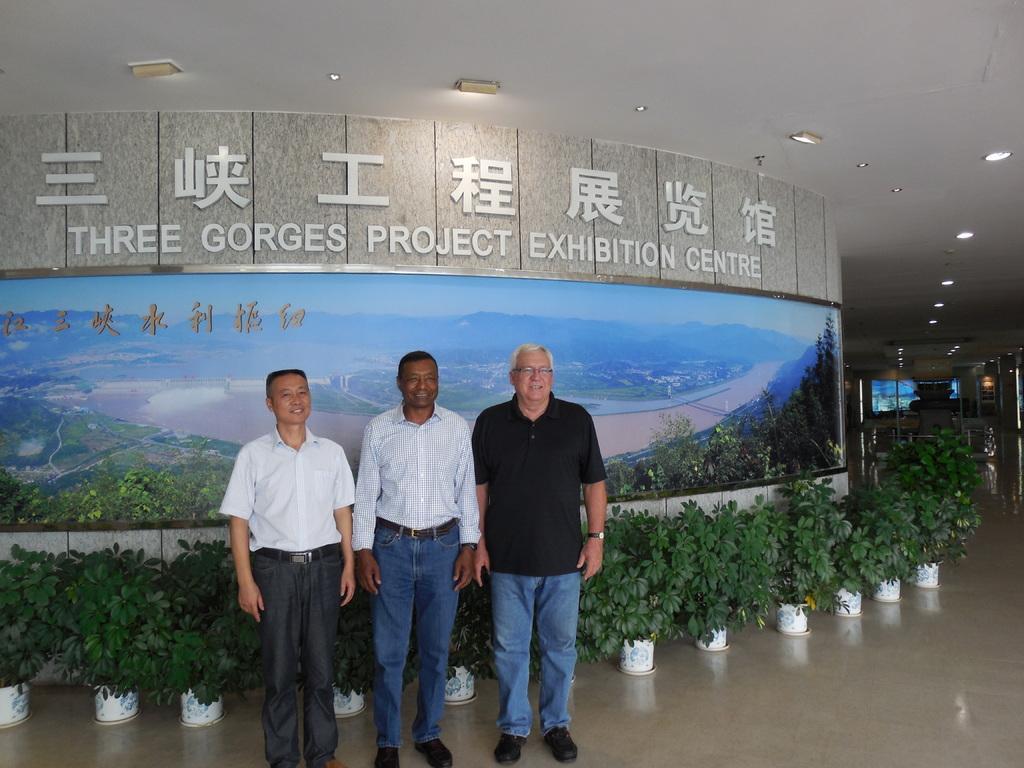Describe this image in one or two sentences. In this image we can see three men are standing on the floor. Behind them, we can see potted plants, banner and a wall. At the top of the image, we can see the roof and lights. 